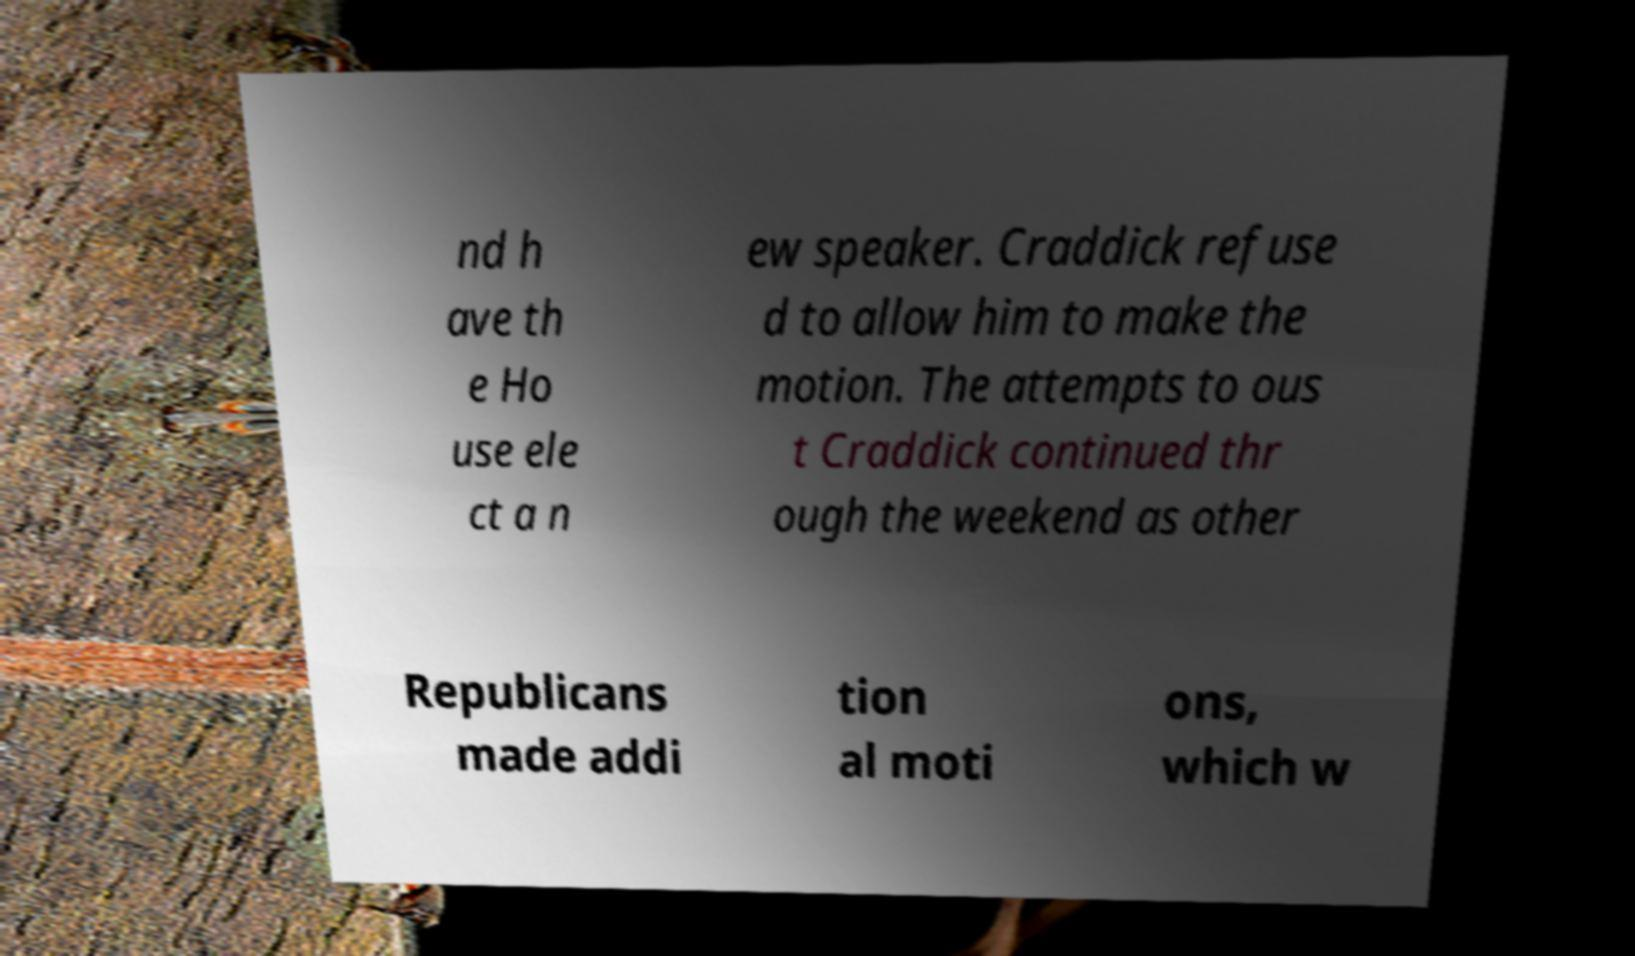There's text embedded in this image that I need extracted. Can you transcribe it verbatim? nd h ave th e Ho use ele ct a n ew speaker. Craddick refuse d to allow him to make the motion. The attempts to ous t Craddick continued thr ough the weekend as other Republicans made addi tion al moti ons, which w 